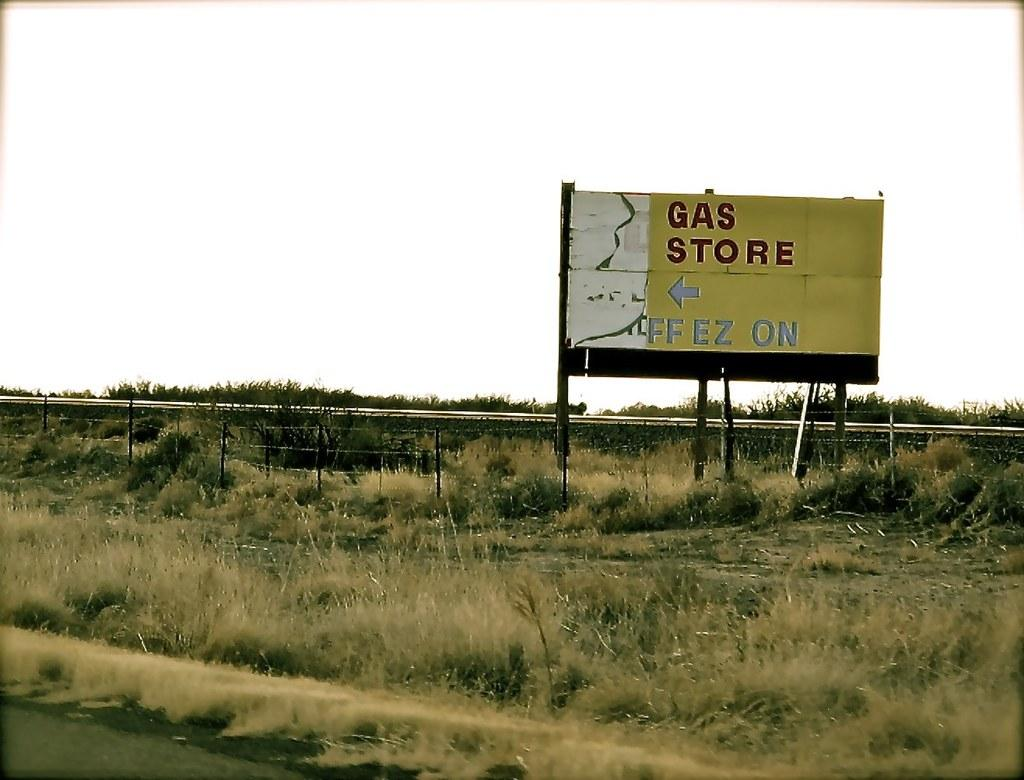What type of vegetation can be seen in the image? There is grass in the image. What type of structure is present in the image? There is a fence in the image. What type of pathway is visible in the image? There is a road in the image. What type of signage is present in the image? There is a text board in the image. What type of natural elements are present in the image? There are plants in the image. What part of the natural environment is visible in the image? The sky is visible in the image. Where is the shop located in the image? There is no shop present in the image. What type of can is visible in the image? There is no can present in the image. What type of emotion is being expressed by the love in the image? There is no love or emotion present in the image. 